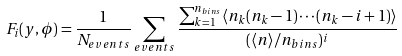Convert formula to latex. <formula><loc_0><loc_0><loc_500><loc_500>F _ { i } ( y , \phi ) = \frac { 1 } { N _ { e v e n t s } } \sum _ { e v e n t s } \frac { \sum _ { k = 1 } ^ { n _ { b i n s } } \langle n _ { k } ( n _ { k } - 1 ) \cdots ( n _ { k } - i + 1 ) \rangle } { ( \langle n \rangle / n _ { b i n s } ) ^ { i } }</formula> 